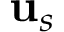<formula> <loc_0><loc_0><loc_500><loc_500>u _ { s }</formula> 